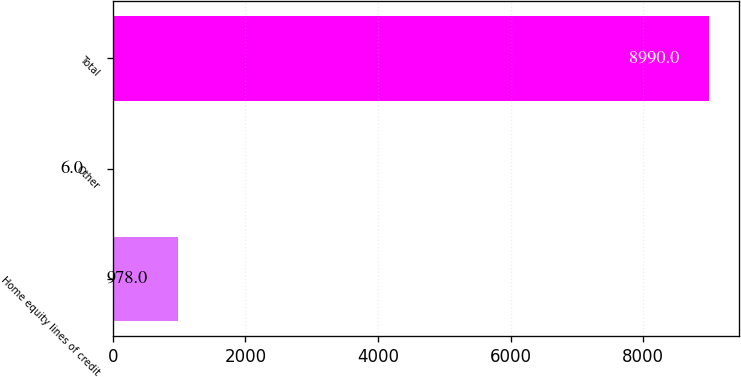Convert chart to OTSL. <chart><loc_0><loc_0><loc_500><loc_500><bar_chart><fcel>Home equity lines of credit<fcel>Other<fcel>Total<nl><fcel>978<fcel>6<fcel>8990<nl></chart> 